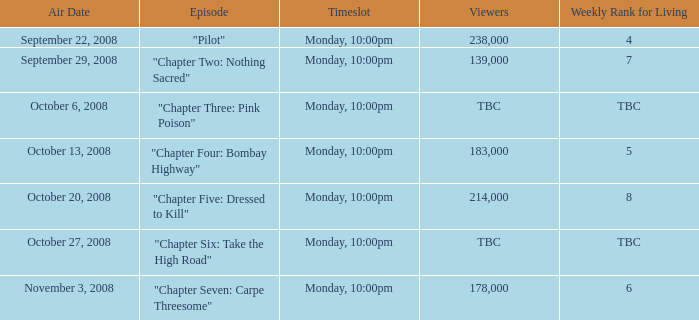What is the weekly rank for living when the air date is october 6, 2008? TBC. 